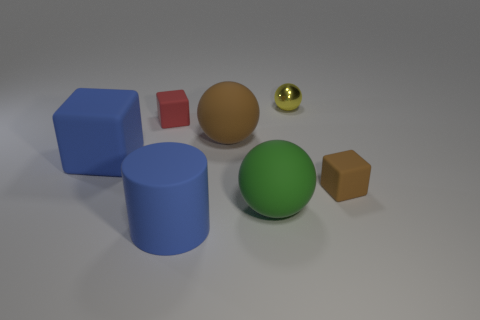What size is the object that is the same color as the big block?
Offer a very short reply. Large. How big is the red object?
Ensure brevity in your answer.  Small. There is another big rubber thing that is the same shape as the red rubber object; what color is it?
Make the answer very short. Blue. Are there any other things that have the same color as the large cylinder?
Your answer should be compact. Yes. Do the ball that is on the right side of the green ball and the brown object that is on the left side of the green rubber object have the same size?
Offer a terse response. No. Are there the same number of red things that are behind the green sphere and blue matte things behind the metallic thing?
Your response must be concise. No. Does the brown sphere have the same size as the matte cube that is to the right of the large blue matte cylinder?
Ensure brevity in your answer.  No. There is a matte object that is to the right of the small yellow metal ball; are there any large brown rubber things that are on the left side of it?
Offer a terse response. Yes. Is there a small blue rubber thing that has the same shape as the tiny shiny thing?
Keep it short and to the point. No. There is a blue thing behind the large object in front of the large green thing; how many green spheres are left of it?
Your answer should be compact. 0. 